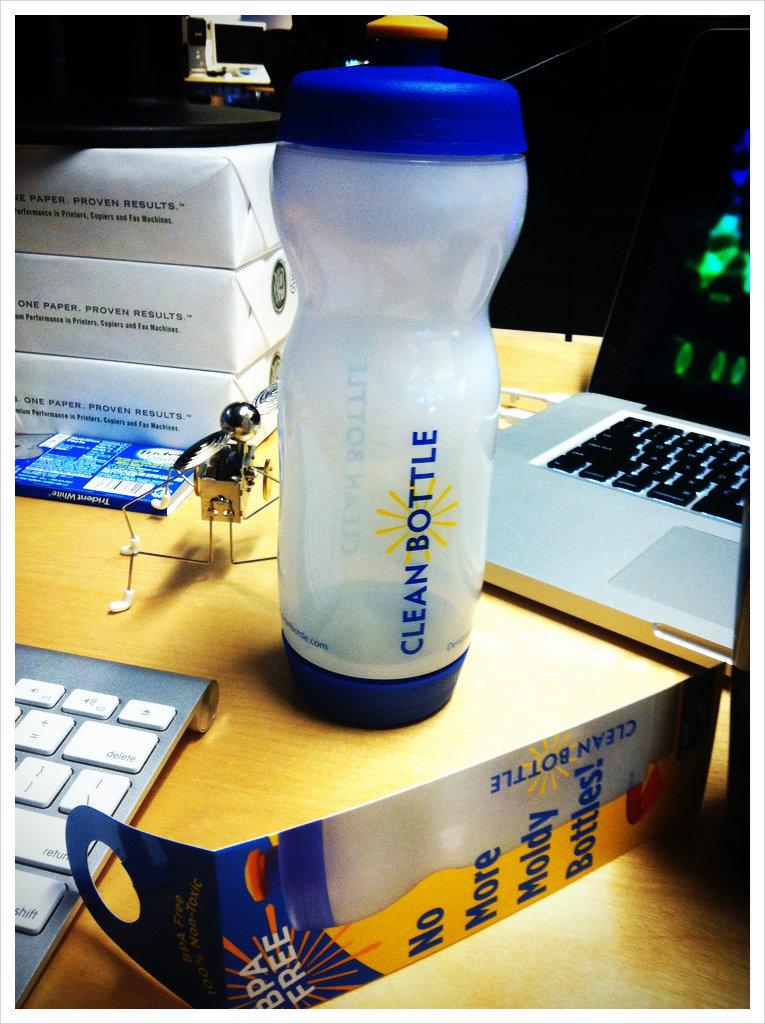What brand of gum is in the blue pack?
Offer a very short reply. Unanswerable. 